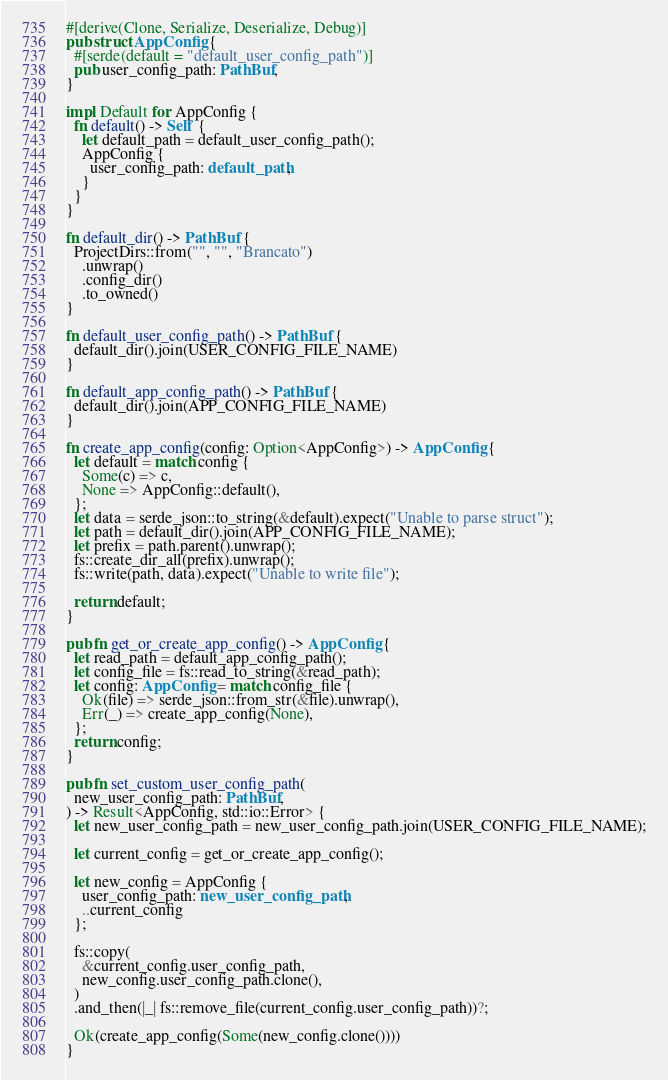<code> <loc_0><loc_0><loc_500><loc_500><_Rust_>#[derive(Clone, Serialize, Deserialize, Debug)]
pub struct AppConfig {
  #[serde(default = "default_user_config_path")]
  pub user_config_path: PathBuf,
}

impl Default for AppConfig {
  fn default() -> Self {
    let default_path = default_user_config_path();
    AppConfig {
      user_config_path: default_path,
    }
  }
}

fn default_dir() -> PathBuf {
  ProjectDirs::from("", "", "Brancato")
    .unwrap()
    .config_dir()
    .to_owned()
}

fn default_user_config_path() -> PathBuf {
  default_dir().join(USER_CONFIG_FILE_NAME)
}

fn default_app_config_path() -> PathBuf {
  default_dir().join(APP_CONFIG_FILE_NAME)
}

fn create_app_config(config: Option<AppConfig>) -> AppConfig {
  let default = match config {
    Some(c) => c,
    None => AppConfig::default(),
  };
  let data = serde_json::to_string(&default).expect("Unable to parse struct");
  let path = default_dir().join(APP_CONFIG_FILE_NAME);
  let prefix = path.parent().unwrap();
  fs::create_dir_all(prefix).unwrap();
  fs::write(path, data).expect("Unable to write file");

  return default;
}

pub fn get_or_create_app_config() -> AppConfig {
  let read_path = default_app_config_path();
  let config_file = fs::read_to_string(&read_path);
  let config: AppConfig = match config_file {
    Ok(file) => serde_json::from_str(&file).unwrap(),
    Err(_) => create_app_config(None),
  };
  return config;
}

pub fn set_custom_user_config_path(
  new_user_config_path: PathBuf,
) -> Result<AppConfig, std::io::Error> {
  let new_user_config_path = new_user_config_path.join(USER_CONFIG_FILE_NAME);

  let current_config = get_or_create_app_config();

  let new_config = AppConfig {
    user_config_path: new_user_config_path,
    ..current_config
  };

  fs::copy(
    &current_config.user_config_path,
    new_config.user_config_path.clone(),
  )
  .and_then(|_| fs::remove_file(current_config.user_config_path))?;

  Ok(create_app_config(Some(new_config.clone())))
}
</code> 